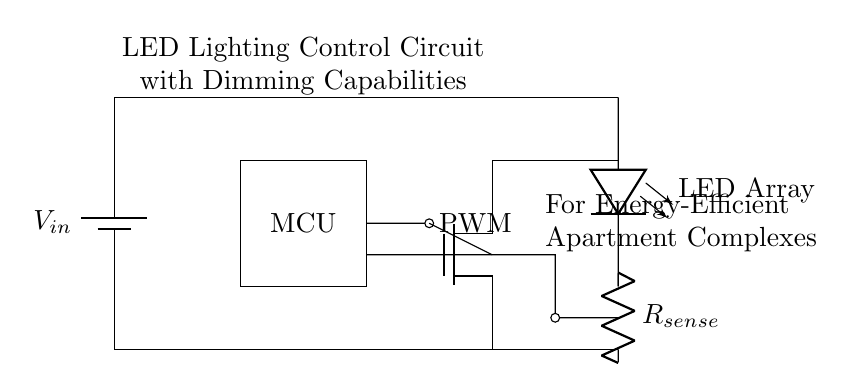What is the function of the MCU in this circuit? The MCU, or microcontroller unit, is responsible for controlling the pulse width modulation (PWM) output which regulates the LED brightness.
Answer: controlling LED brightness How many components are connected in series between the power supply and the LED array? There are three main components connected in series: the MCU (for PWM), the MOSFET (for switching the LEDs), and the LED array itself. Each component processes the current sequentially.
Answer: three What type of transistor is used in this circuit? The circuit uses an N-channel MOSFET, which is important for switching and amplifying signals as it allows current to flow when activated by a PWM signal.
Answer: N-channel MOSFET What does the current sensing resistor do? The current sensing resistor measures the amount of current flowing to the LED array, allowing for feedback to the MCU to adjust the brightness.
Answer: measures current How does PWM affect the LED lighting in this circuit? PWM controls the brightness of the LEDs by rapidly turning them on and off at varying duty cycles, effectively changing the average power delivered to the LEDs.
Answer: regulates brightness What is the role of the feedback connection in this circuit? The feedback connection allows the current sensing resistor to relay information back to the MCU about the current flowing to the LEDs, enabling adjustments to the PWM signal to maintain desired brightness levels.
Answer: maintains desired brightness 